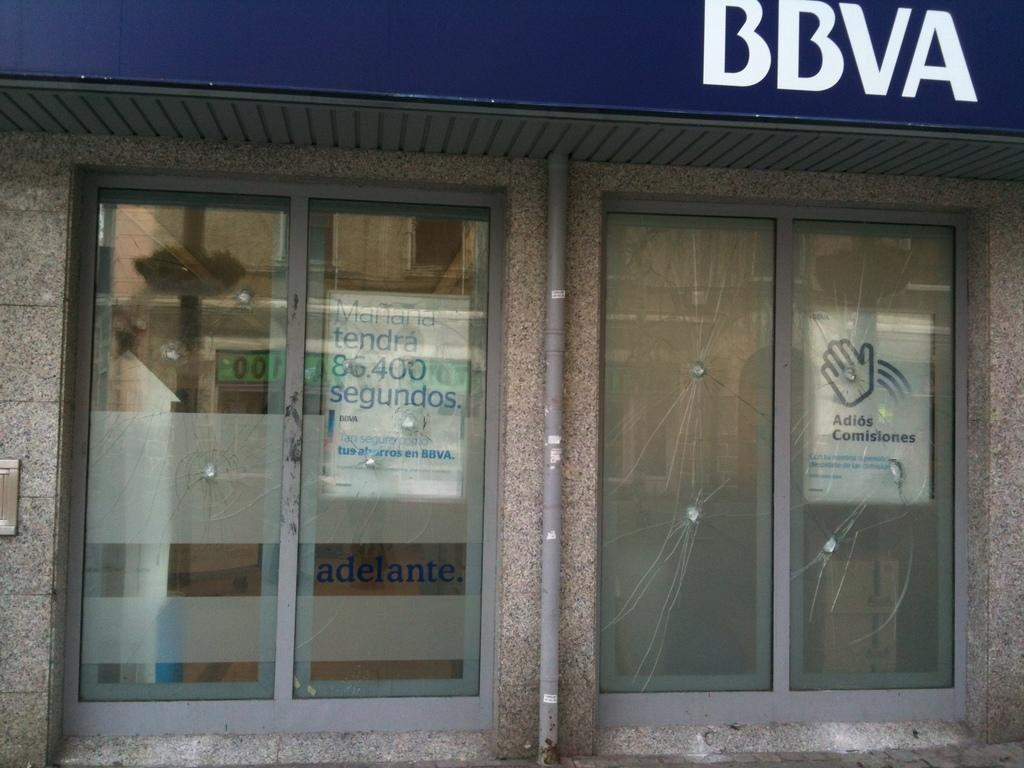What type of structure is present in the image? There is a building in the image. What feature of the building is mentioned in the facts? The building has doors. Are there any additional details about the building's exterior? Yes, there is a pipe on the wall of the building. What else can be seen in the image related to the building? There are notices and a name board on the building. What type of cap is the sister wearing in the image? There is no mention of a sister or a cap in the image or the provided facts. 